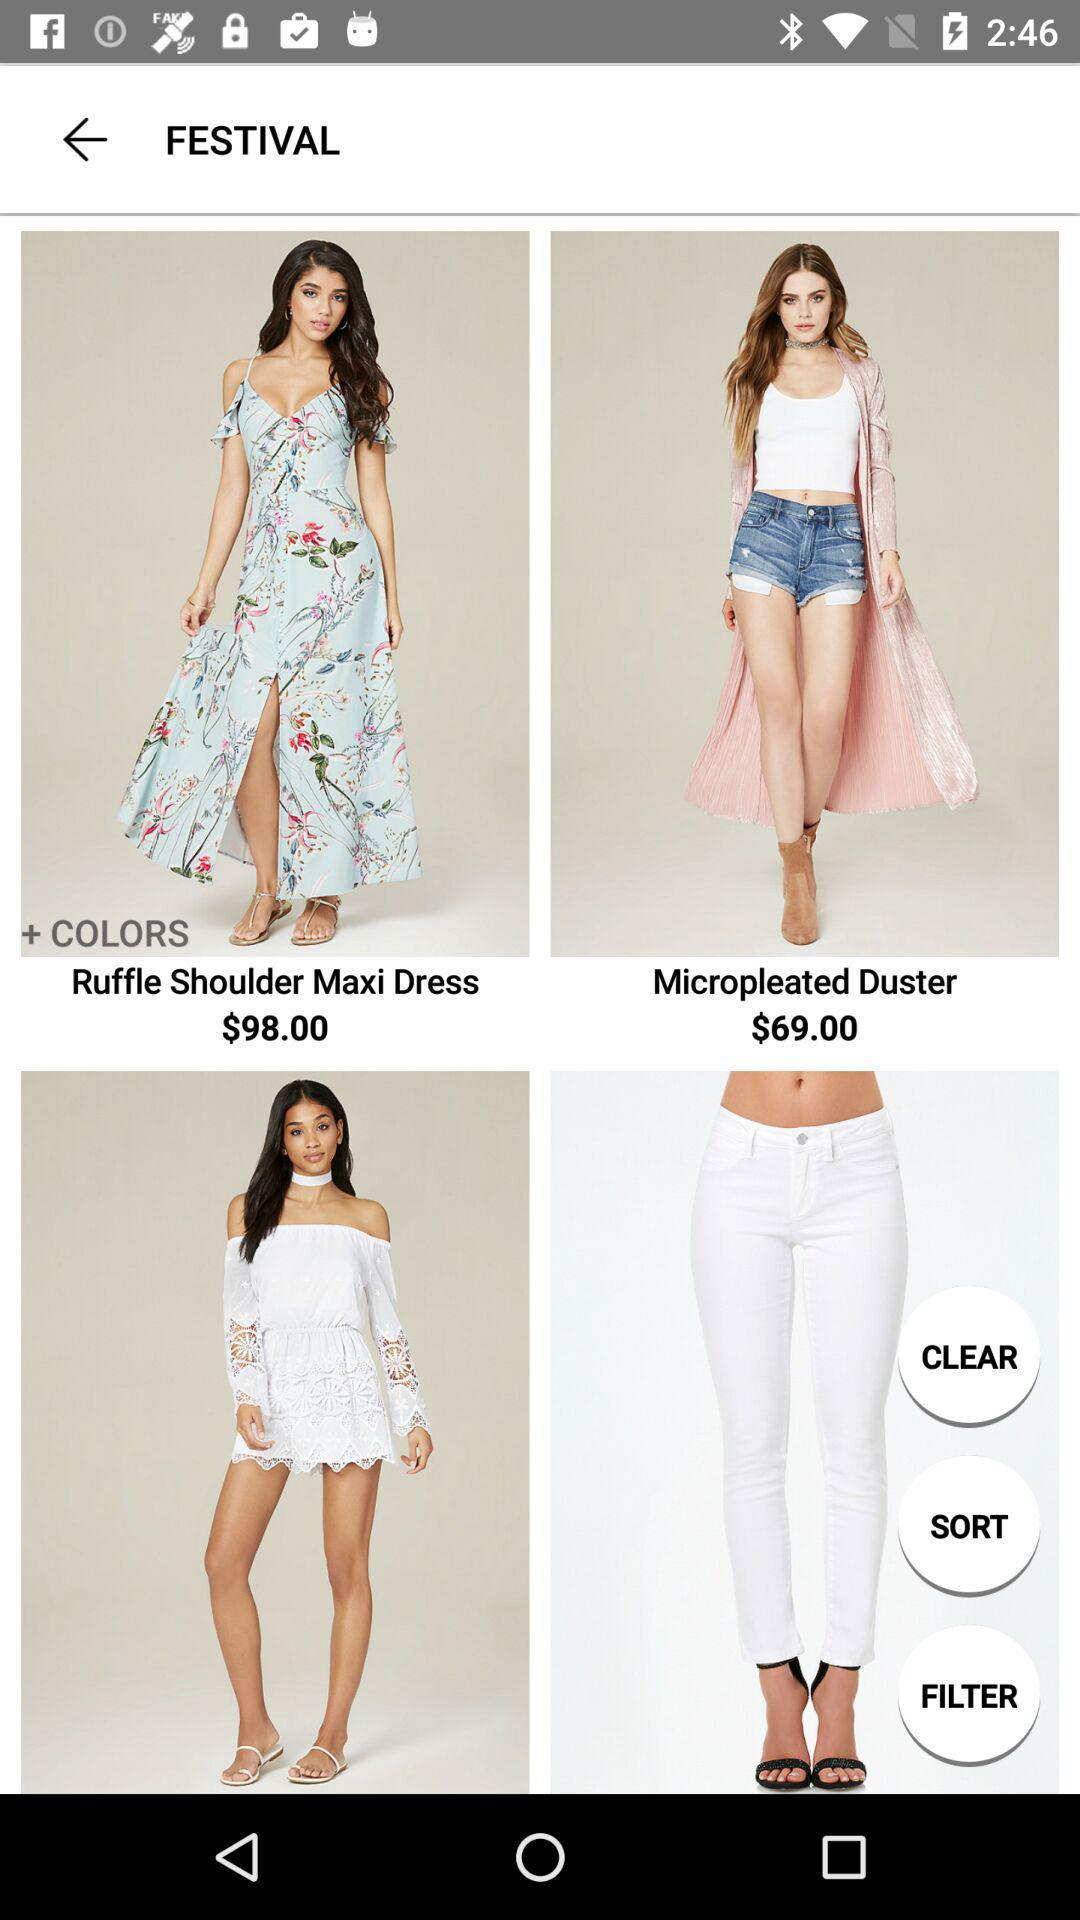How many items have a price less than $100?
Answer the question using a single word or phrase. 2 